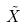<formula> <loc_0><loc_0><loc_500><loc_500>\tilde { X }</formula> 